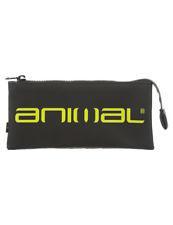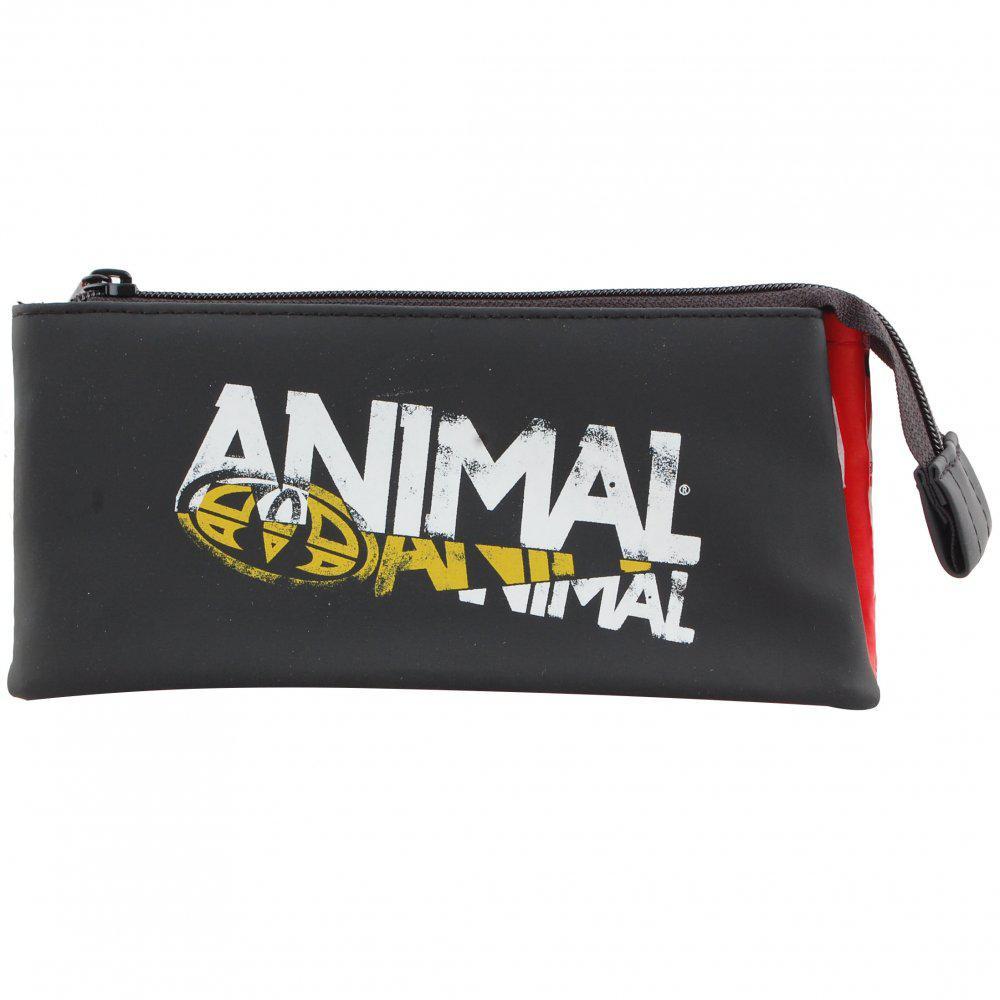The first image is the image on the left, the second image is the image on the right. Analyze the images presented: Is the assertion "There is the word animal that is printed in white and has a dot after the word in both images." valid? Answer yes or no. No. The first image is the image on the left, the second image is the image on the right. Evaluate the accuracy of this statement regarding the images: "Both pouches have the word """"animal"""" on them.". Is it true? Answer yes or no. Yes. 